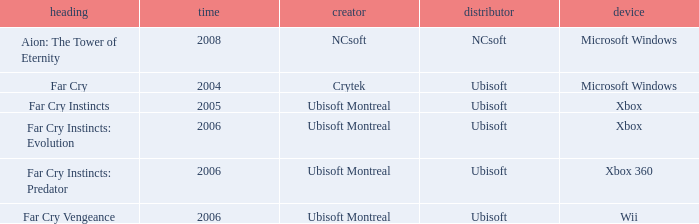Which title has xbox as the platform with a year prior to 2006? Far Cry Instincts. 